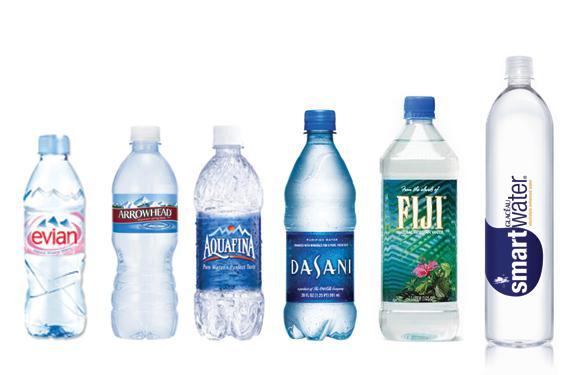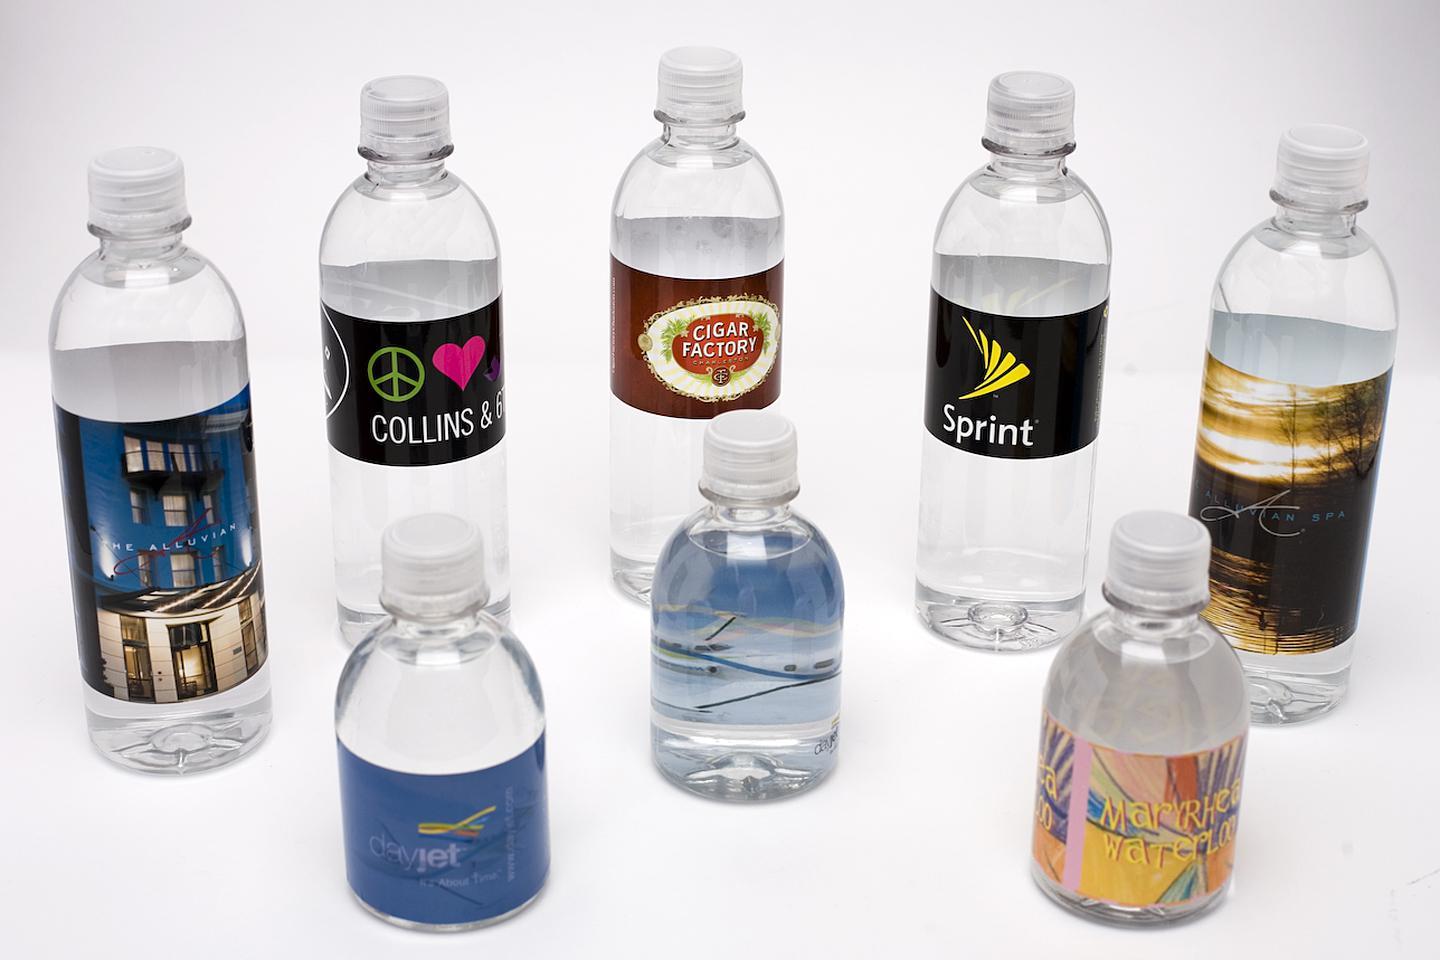The first image is the image on the left, the second image is the image on the right. Analyze the images presented: Is the assertion "There are two more bottles in one of the images than in the other." valid? Answer yes or no. Yes. The first image is the image on the left, the second image is the image on the right. Analyze the images presented: Is the assertion "There are less than eight disposable plastic water bottles" valid? Answer yes or no. No. 